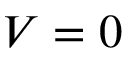Convert formula to latex. <formula><loc_0><loc_0><loc_500><loc_500>V = 0</formula> 